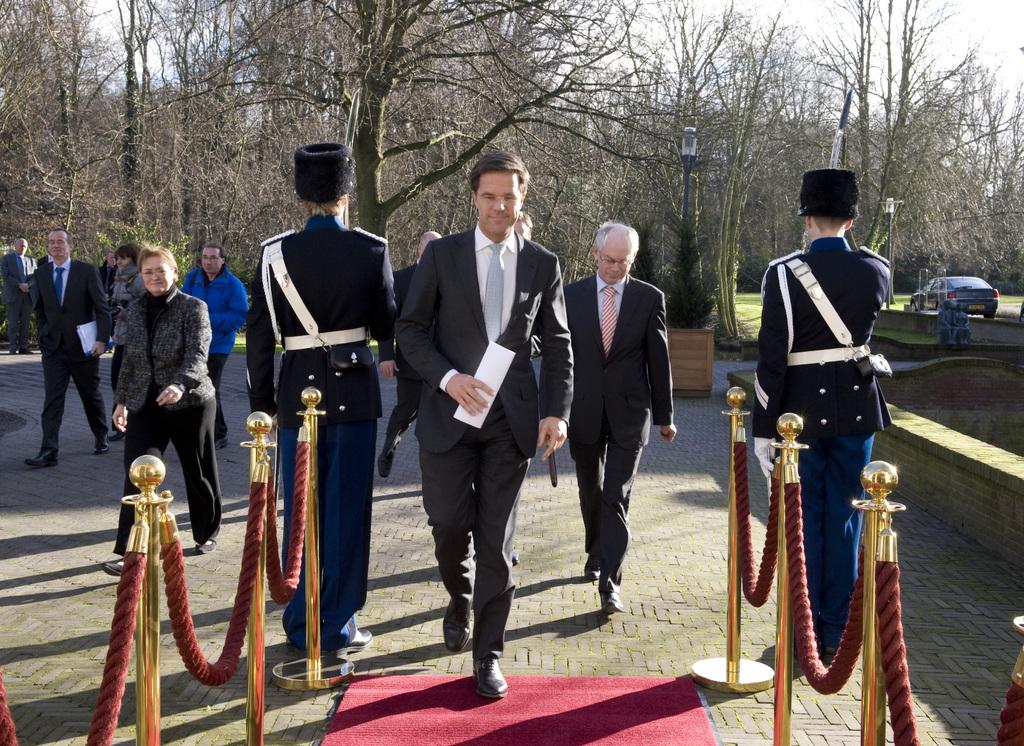What are the people in the image doing? The people in the image are carrying objects. What structures can be seen in the image? There are poles in the image. What material is present in the image? There is rope in the image. What can be used for resting or sitting in the image? There is a mat in the image. What type of transportation is visible in the image? There are vehicles in the image. What type of natural vegetation is present in the image? There are trees in the image. What is on the floor in the image? There are objects on the floor in the image. What part of the natural environment is visible in the image? The sky is visible in the image. What type of pie is being served in the image? There is no pie present in the image. What news event is being discussed by the people in the image? There is no indication of a news event or discussion in the image. 